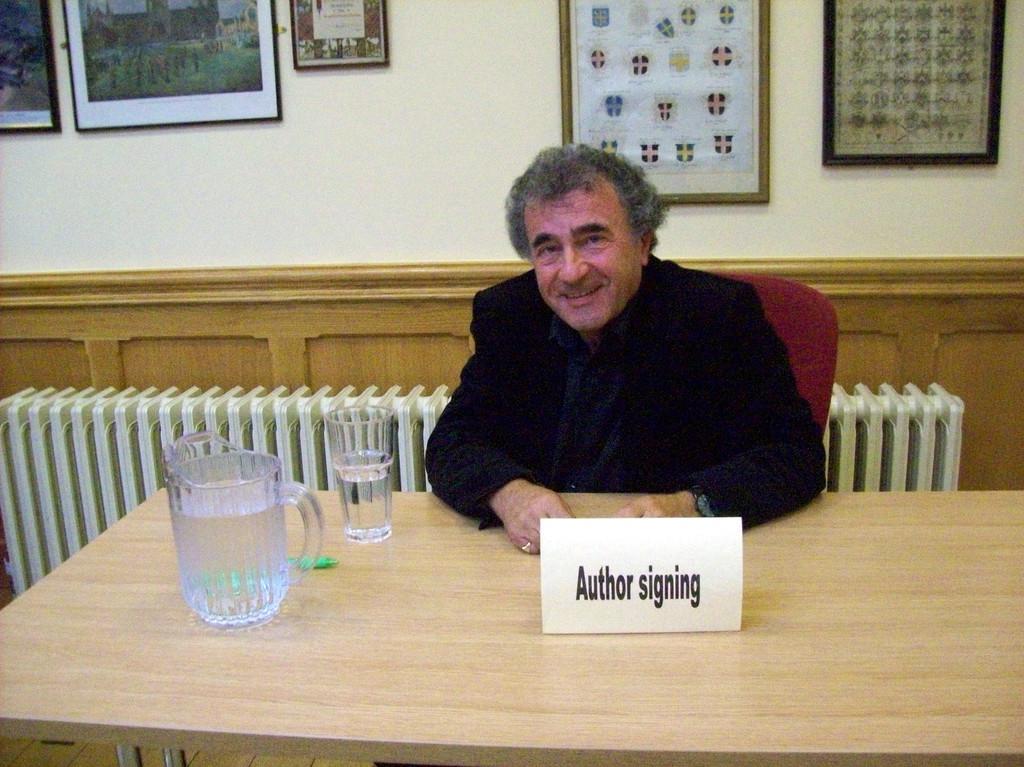How would you summarize this image in a sentence or two? In center we can see man sitting on chair and he is smiling. In front of him we can see table,on table we can see glass and mug. And back there is a wall and photo frame. 